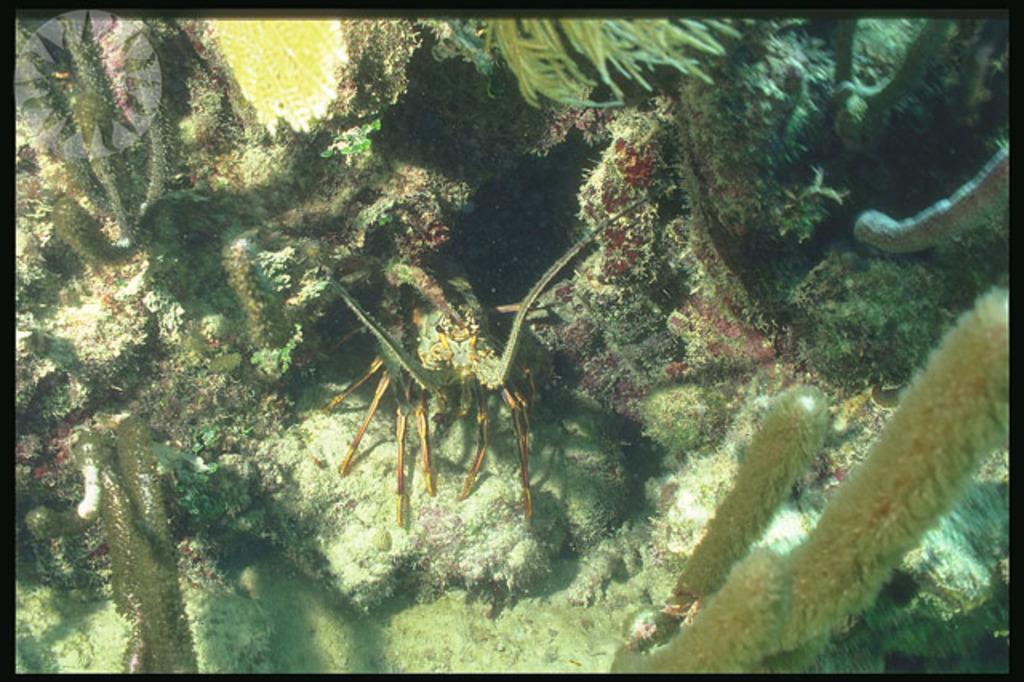How would you summarize this image in a sentence or two? Here I can see an insect and few marine species inside the water. 